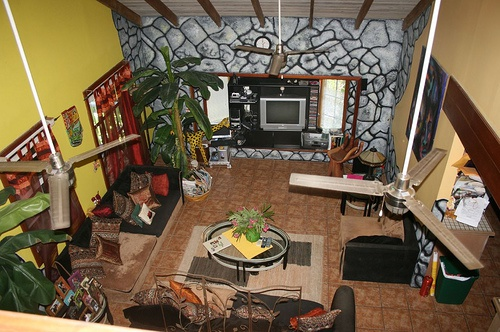Describe the objects in this image and their specific colors. I can see potted plant in olive, black, darkgreen, and gray tones, couch in olive, black, maroon, and gray tones, potted plant in olive, black, and darkgreen tones, couch in olive, black, maroon, and gray tones, and tv in olive, darkgray, gray, and black tones in this image. 